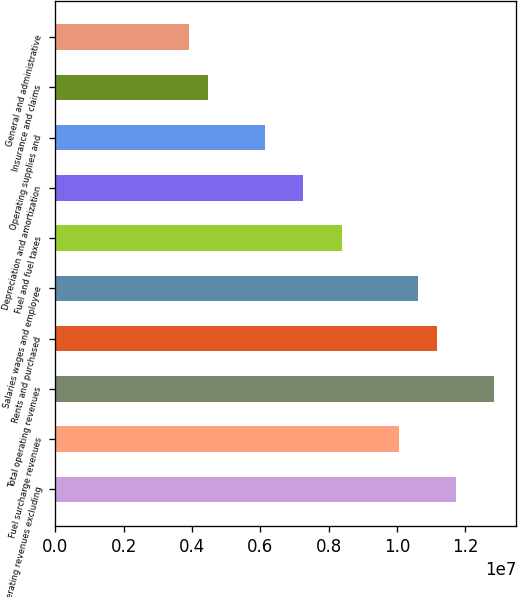Convert chart. <chart><loc_0><loc_0><loc_500><loc_500><bar_chart><fcel>Operating revenues excluding<fcel>Fuel surcharge revenues<fcel>Total operating revenues<fcel>Rents and purchased<fcel>Salaries wages and employee<fcel>Fuel and fuel taxes<fcel>Depreciation and amortization<fcel>Operating supplies and<fcel>Insurance and claims<fcel>General and administrative<nl><fcel>1.17276e+07<fcel>1.00522e+07<fcel>1.28445e+07<fcel>1.11691e+07<fcel>1.06107e+07<fcel>8.37686e+06<fcel>7.25994e+06<fcel>6.14303e+06<fcel>4.46766e+06<fcel>3.9092e+06<nl></chart> 